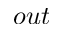<formula> <loc_0><loc_0><loc_500><loc_500>o u t</formula> 